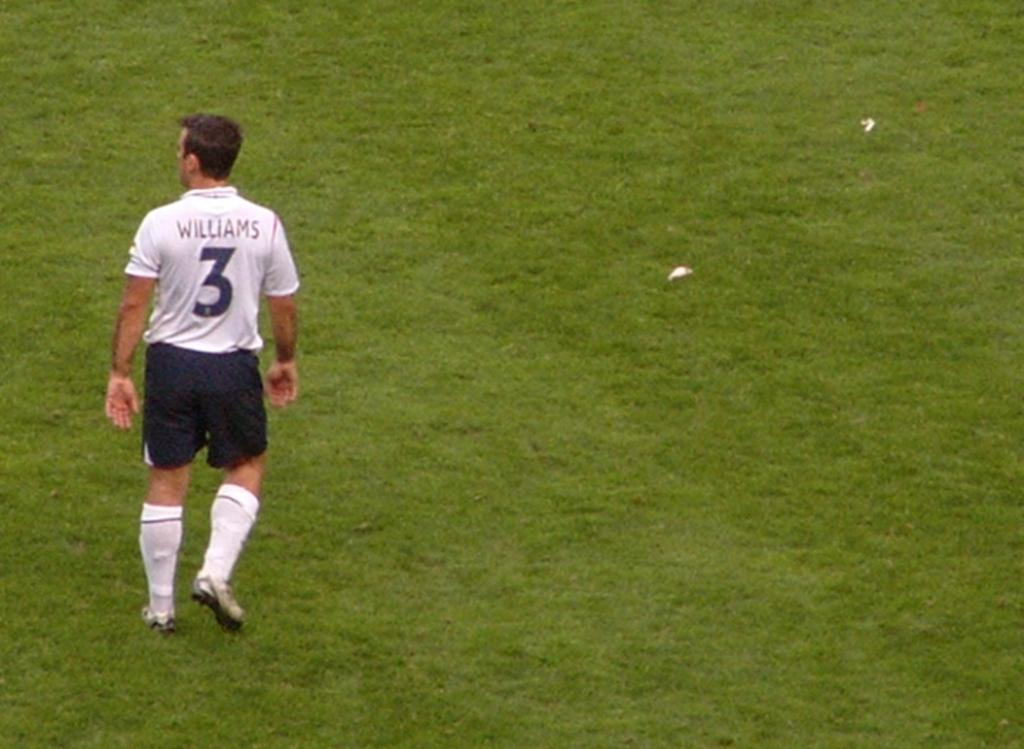<image>
Give a short and clear explanation of the subsequent image. Player number 3 named Williams walks on an empty green field 